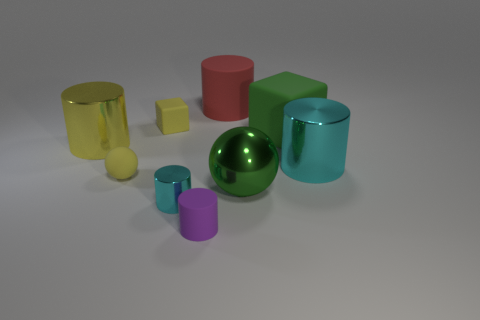There is a matte object in front of the tiny metal thing; does it have the same shape as the cyan metal object to the left of the red cylinder?
Offer a very short reply. Yes. How many things are either tiny metal things or cyan cylinders?
Make the answer very short. 2. What size is the red matte thing that is the same shape as the small cyan shiny thing?
Keep it short and to the point. Large. Is the number of rubber things that are behind the tiny metallic cylinder greater than the number of big green cubes?
Provide a short and direct response. Yes. Are the tiny purple object and the green ball made of the same material?
Your response must be concise. No. How many things are big objects right of the red rubber object or big yellow metal cylinders in front of the yellow block?
Your answer should be compact. 4. What color is the large matte thing that is the same shape as the tiny cyan object?
Your answer should be very brief. Red. What number of other shiny cylinders have the same color as the small shiny cylinder?
Ensure brevity in your answer.  1. Is the big rubber block the same color as the metal ball?
Your answer should be very brief. Yes. How many objects are either matte cylinders in front of the tiny yellow sphere or purple shiny cylinders?
Offer a very short reply. 1. 